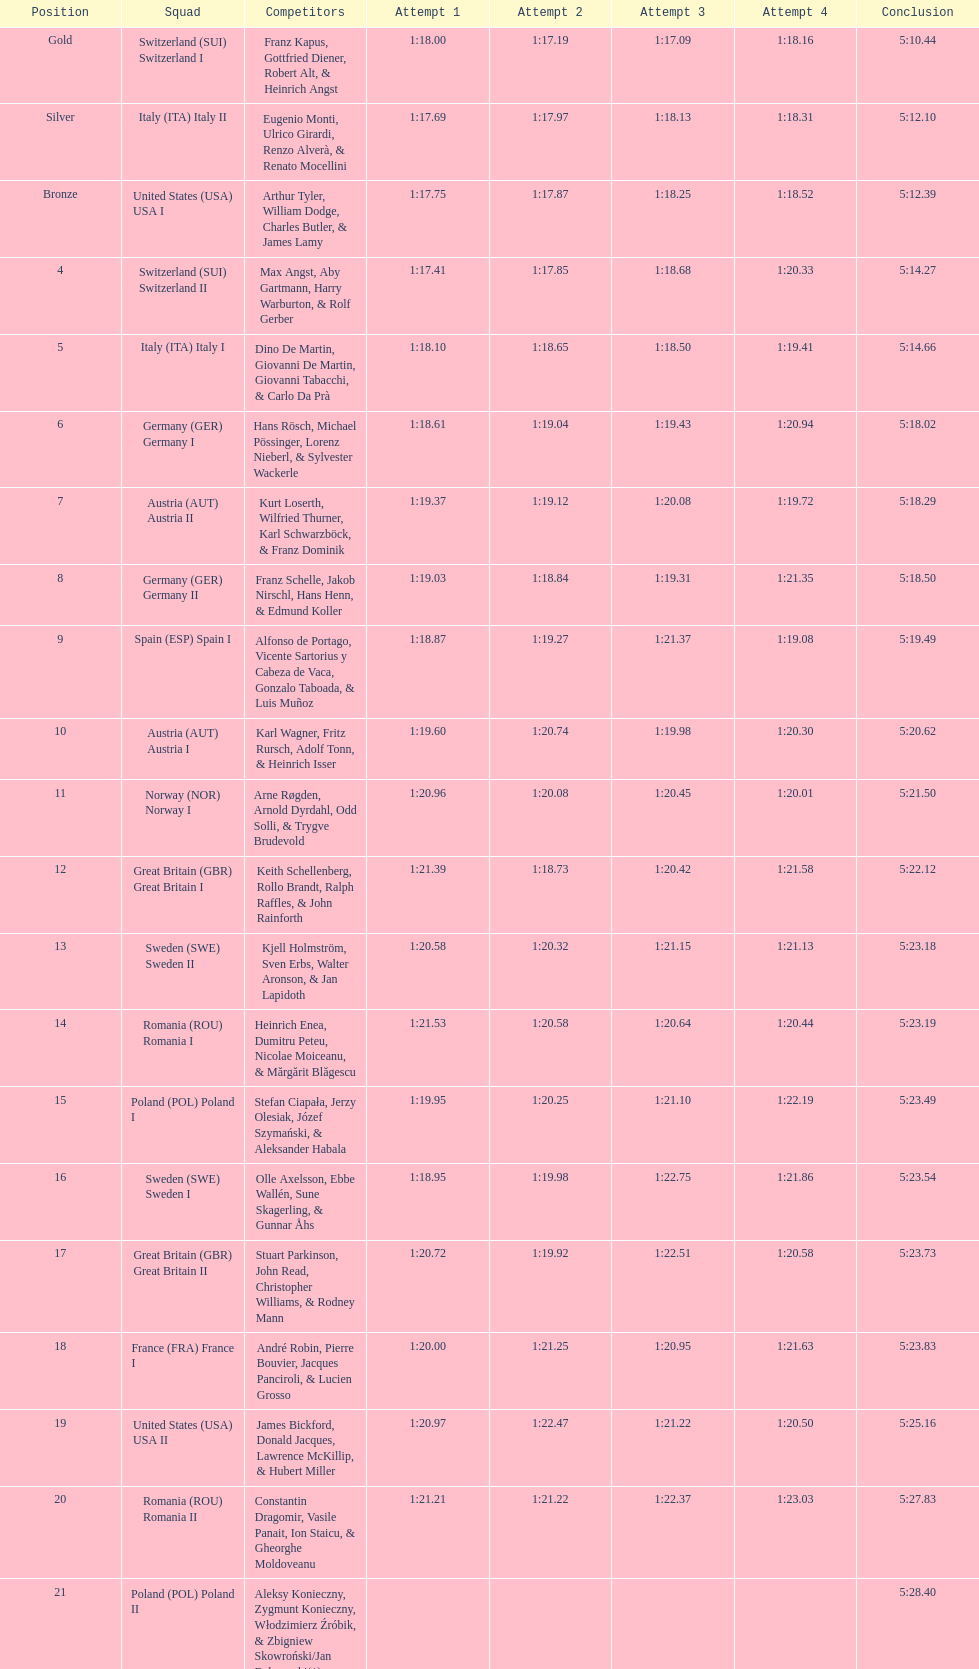Would you be able to parse every entry in this table? {'header': ['Position', 'Squad', 'Competitors', 'Attempt 1', 'Attempt 2', 'Attempt 3', 'Attempt 4', 'Conclusion'], 'rows': [['Gold', 'Switzerland\xa0(SUI) Switzerland I', 'Franz Kapus, Gottfried Diener, Robert Alt, & Heinrich Angst', '1:18.00', '1:17.19', '1:17.09', '1:18.16', '5:10.44'], ['Silver', 'Italy\xa0(ITA) Italy II', 'Eugenio Monti, Ulrico Girardi, Renzo Alverà, & Renato Mocellini', '1:17.69', '1:17.97', '1:18.13', '1:18.31', '5:12.10'], ['Bronze', 'United States\xa0(USA) USA I', 'Arthur Tyler, William Dodge, Charles Butler, & James Lamy', '1:17.75', '1:17.87', '1:18.25', '1:18.52', '5:12.39'], ['4', 'Switzerland\xa0(SUI) Switzerland II', 'Max Angst, Aby Gartmann, Harry Warburton, & Rolf Gerber', '1:17.41', '1:17.85', '1:18.68', '1:20.33', '5:14.27'], ['5', 'Italy\xa0(ITA) Italy I', 'Dino De Martin, Giovanni De Martin, Giovanni Tabacchi, & Carlo Da Prà', '1:18.10', '1:18.65', '1:18.50', '1:19.41', '5:14.66'], ['6', 'Germany\xa0(GER) Germany I', 'Hans Rösch, Michael Pössinger, Lorenz Nieberl, & Sylvester Wackerle', '1:18.61', '1:19.04', '1:19.43', '1:20.94', '5:18.02'], ['7', 'Austria\xa0(AUT) Austria II', 'Kurt Loserth, Wilfried Thurner, Karl Schwarzböck, & Franz Dominik', '1:19.37', '1:19.12', '1:20.08', '1:19.72', '5:18.29'], ['8', 'Germany\xa0(GER) Germany II', 'Franz Schelle, Jakob Nirschl, Hans Henn, & Edmund Koller', '1:19.03', '1:18.84', '1:19.31', '1:21.35', '5:18.50'], ['9', 'Spain\xa0(ESP) Spain I', 'Alfonso de Portago, Vicente Sartorius y Cabeza de Vaca, Gonzalo Taboada, & Luis Muñoz', '1:18.87', '1:19.27', '1:21.37', '1:19.08', '5:19.49'], ['10', 'Austria\xa0(AUT) Austria I', 'Karl Wagner, Fritz Rursch, Adolf Tonn, & Heinrich Isser', '1:19.60', '1:20.74', '1:19.98', '1:20.30', '5:20.62'], ['11', 'Norway\xa0(NOR) Norway I', 'Arne Røgden, Arnold Dyrdahl, Odd Solli, & Trygve Brudevold', '1:20.96', '1:20.08', '1:20.45', '1:20.01', '5:21.50'], ['12', 'Great Britain\xa0(GBR) Great Britain I', 'Keith Schellenberg, Rollo Brandt, Ralph Raffles, & John Rainforth', '1:21.39', '1:18.73', '1:20.42', '1:21.58', '5:22.12'], ['13', 'Sweden\xa0(SWE) Sweden II', 'Kjell Holmström, Sven Erbs, Walter Aronson, & Jan Lapidoth', '1:20.58', '1:20.32', '1:21.15', '1:21.13', '5:23.18'], ['14', 'Romania\xa0(ROU) Romania I', 'Heinrich Enea, Dumitru Peteu, Nicolae Moiceanu, & Mărgărit Blăgescu', '1:21.53', '1:20.58', '1:20.64', '1:20.44', '5:23.19'], ['15', 'Poland\xa0(POL) Poland I', 'Stefan Ciapała, Jerzy Olesiak, Józef Szymański, & Aleksander Habala', '1:19.95', '1:20.25', '1:21.10', '1:22.19', '5:23.49'], ['16', 'Sweden\xa0(SWE) Sweden I', 'Olle Axelsson, Ebbe Wallén, Sune Skagerling, & Gunnar Åhs', '1:18.95', '1:19.98', '1:22.75', '1:21.86', '5:23.54'], ['17', 'Great Britain\xa0(GBR) Great Britain II', 'Stuart Parkinson, John Read, Christopher Williams, & Rodney Mann', '1:20.72', '1:19.92', '1:22.51', '1:20.58', '5:23.73'], ['18', 'France\xa0(FRA) France I', 'André Robin, Pierre Bouvier, Jacques Panciroli, & Lucien Grosso', '1:20.00', '1:21.25', '1:20.95', '1:21.63', '5:23.83'], ['19', 'United States\xa0(USA) USA II', 'James Bickford, Donald Jacques, Lawrence McKillip, & Hubert Miller', '1:20.97', '1:22.47', '1:21.22', '1:20.50', '5:25.16'], ['20', 'Romania\xa0(ROU) Romania II', 'Constantin Dragomir, Vasile Panait, Ion Staicu, & Gheorghe Moldoveanu', '1:21.21', '1:21.22', '1:22.37', '1:23.03', '5:27.83'], ['21', 'Poland\xa0(POL) Poland II', 'Aleksy Konieczny, Zygmunt Konieczny, Włodzimierz Źróbik, & Zbigniew Skowroński/Jan Dąbrowski(*)', '', '', '', '', '5:28.40']]} How many teams did germany have? 2. 